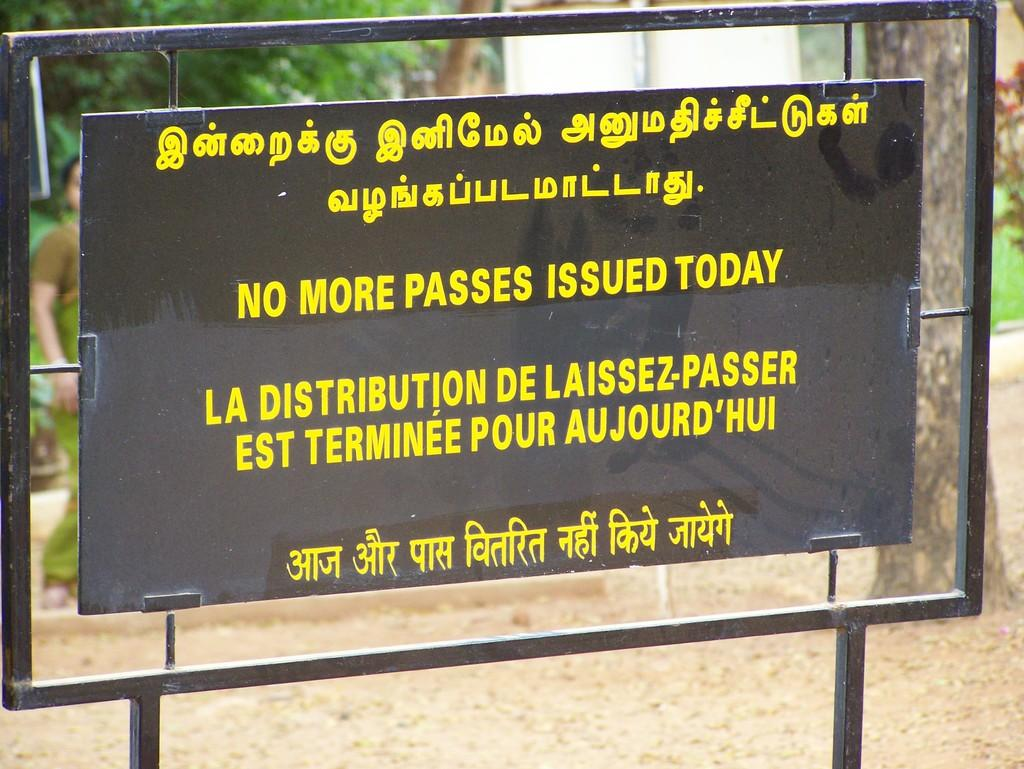<image>
Create a compact narrative representing the image presented. A black sign with yellow letters in several languages saying No More Passes Issued Today. 